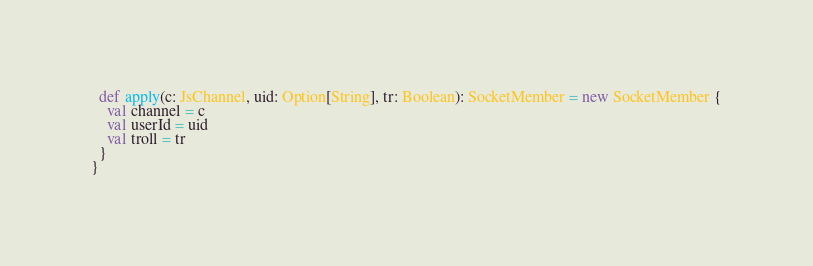<code> <loc_0><loc_0><loc_500><loc_500><_Scala_>  def apply(c: JsChannel, uid: Option[String], tr: Boolean): SocketMember = new SocketMember {
    val channel = c
    val userId = uid
    val troll = tr
  }
}
</code> 